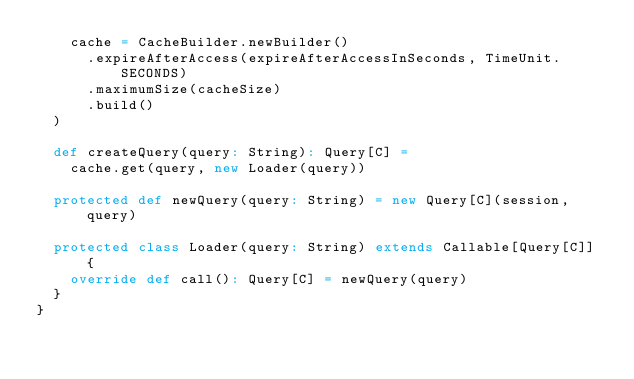<code> <loc_0><loc_0><loc_500><loc_500><_Scala_>    cache = CacheBuilder.newBuilder()
      .expireAfterAccess(expireAfterAccessInSeconds, TimeUnit.SECONDS)
      .maximumSize(cacheSize)
      .build()
  )

  def createQuery(query: String): Query[C] =
    cache.get(query, new Loader(query))

  protected def newQuery(query: String) = new Query[C](session, query)

  protected class Loader(query: String) extends Callable[Query[C]] {
    override def call(): Query[C] = newQuery(query)
  }
}
</code> 